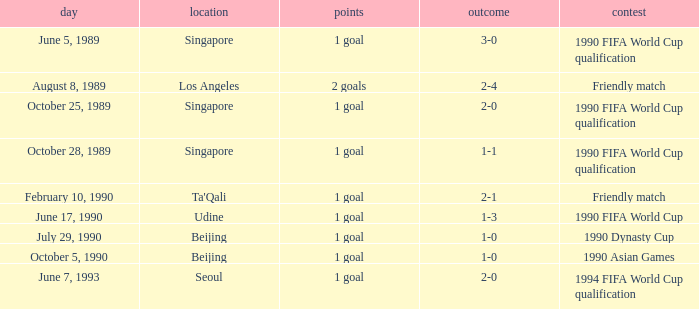What is the score of the match on July 29, 1990? 1 goal. 